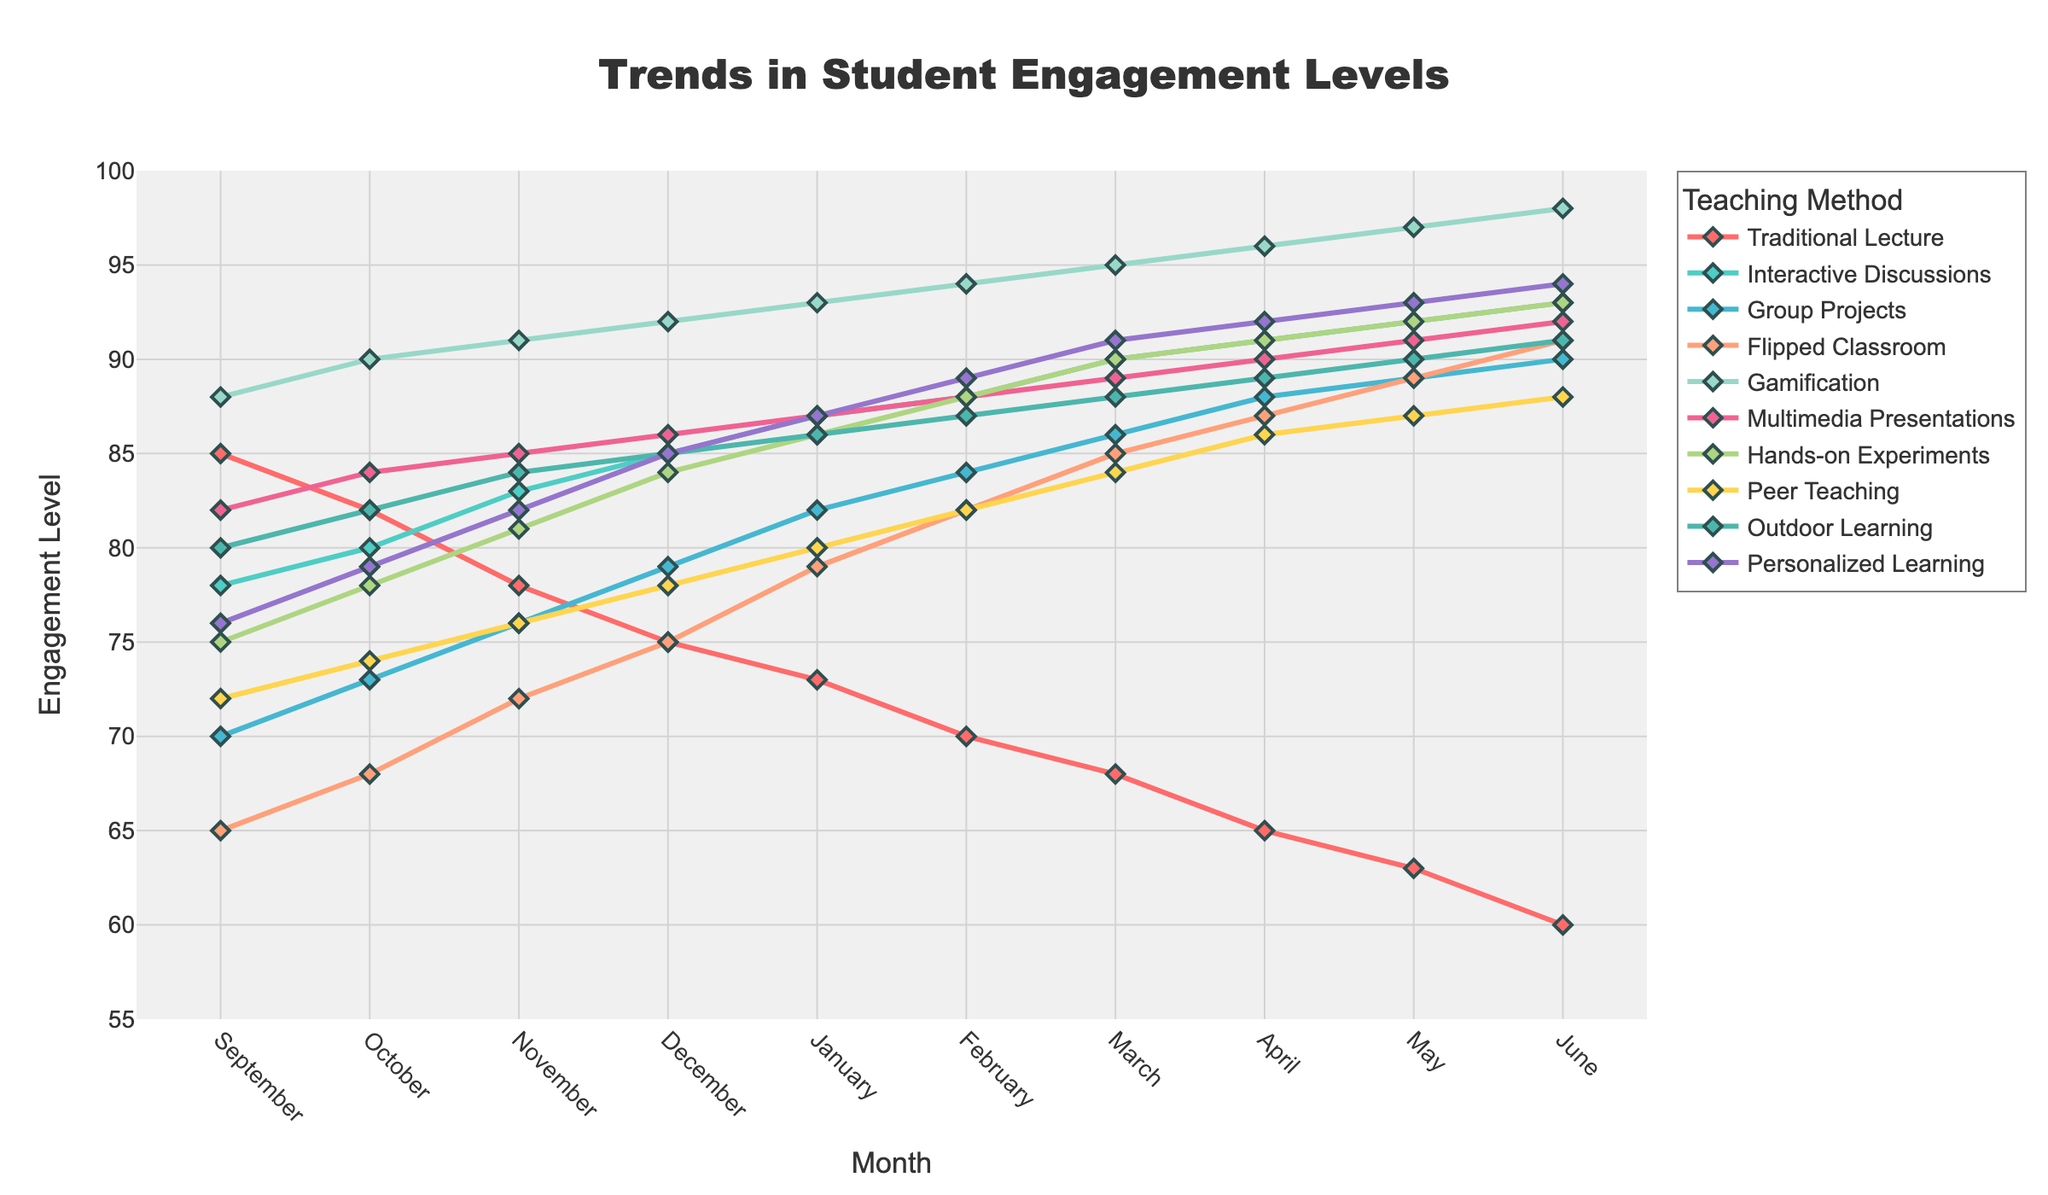Which teaching method showed the highest engagement levels in June? Compare the engagement levels of all teaching methods in June. Gamification has the highest level at 98.
Answer: Gamification What was the difference in engagement levels between Traditional Lecture and Interactive Discussions in December? In December, the engagement level for Traditional Lecture is 75, and for Interactive Discussions is 85. The difference is 85 - 75 = 10.
Answer: 10 Which two teaching methods had nearly the same engagement levels at the beginning of the year in September? Look at the values in September. Traditional Lecture (85) and Multimedia Presentations (82) are close, as well as Peer Teaching (72) and Personalized Learning (76).
Answer: Traditional Lecture and Multimedia Presentations Between which months did the Flipped Classroom method see the highest increase in student engagement levels? Compare the month-to-month differences for the Flipped Classroom. The highest increase is between January (79) and February (82), an increase of 3.
Answer: January and February By how many points did Hands-on Experiments' engagement increase from September to June? Engagement for Hands-on Experiments in September is 75, and in June is 93. The increase is 93 - 75 = 18.
Answer: 18 Which teaching method had the most stable engagement levels throughout the school year? Examine the trends for all teaching methods. Gamification had little variation, with levels steadily increasing and remaining high.
Answer: Gamification What is the average engagement level for Group Projects from September to June? Calculate the sum of Group Projects engagement levels: 70+73+76+79+82+84+86+88+89+90 = 817. Average = 817 / 10 = 81.7.
Answer: 81.7 Which teaching method saw the biggest drop in engagement from September to June? Compare initial and final values for all methods. Traditional Lecture dropped from 85 to 60, the largest drop of 25 points.
Answer: Traditional Lecture What month saw the highest average engagement level across all methods? Sum engagement levels for each month and find the month with the highest total. June has the highest sum, indicating the highest average.
Answer: June 